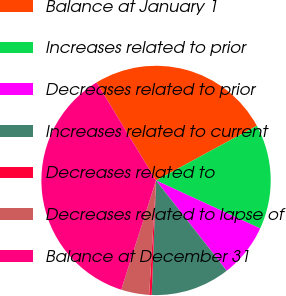Convert chart. <chart><loc_0><loc_0><loc_500><loc_500><pie_chart><fcel>Balance at January 1<fcel>Increases related to prior<fcel>Decreases related to prior<fcel>Increases related to current<fcel>Decreases related to<fcel>Decreases related to lapse of<fcel>Balance at December 31<nl><fcel>25.77%<fcel>14.78%<fcel>7.56%<fcel>11.17%<fcel>0.35%<fcel>3.96%<fcel>36.41%<nl></chart> 